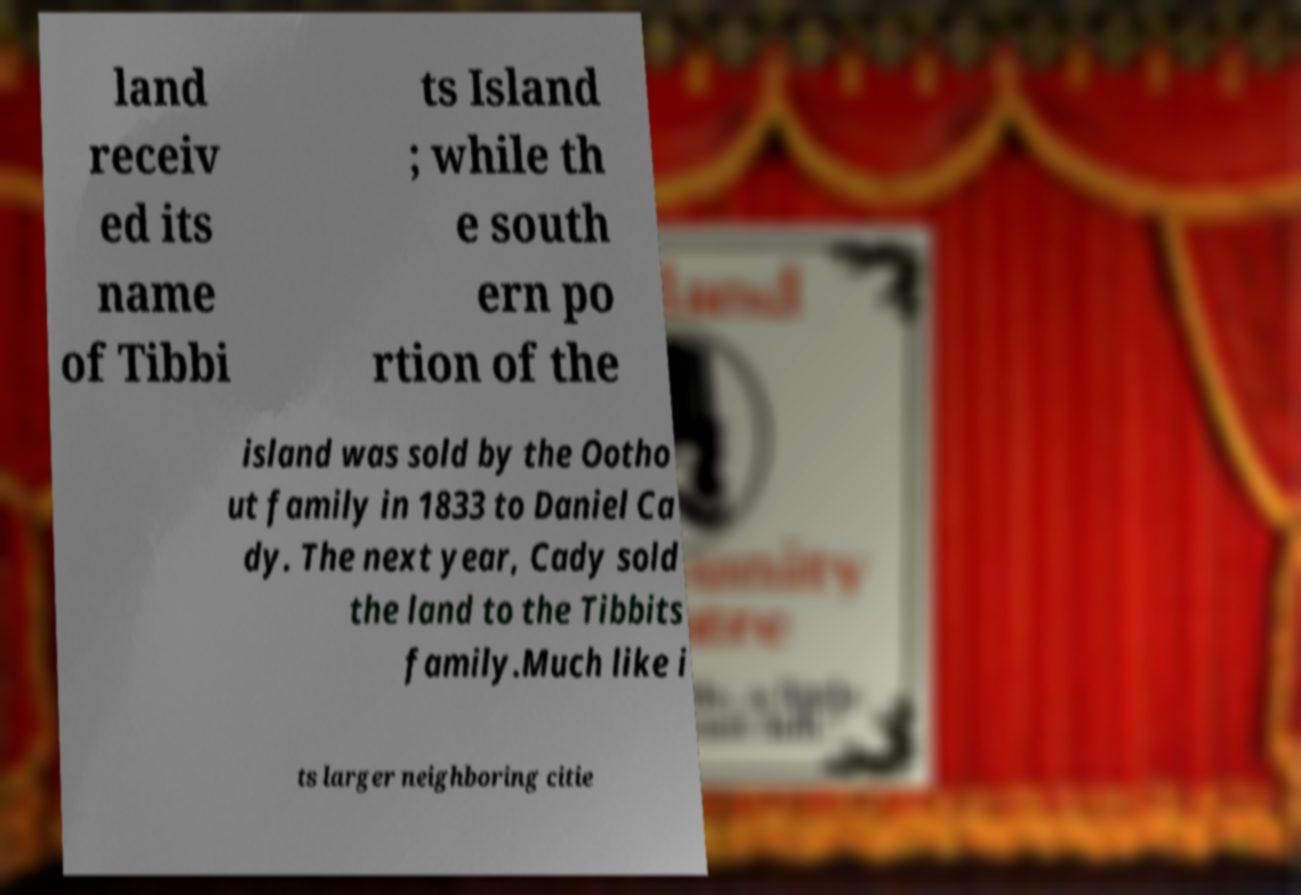I need the written content from this picture converted into text. Can you do that? land receiv ed its name of Tibbi ts Island ; while th e south ern po rtion of the island was sold by the Ootho ut family in 1833 to Daniel Ca dy. The next year, Cady sold the land to the Tibbits family.Much like i ts larger neighboring citie 